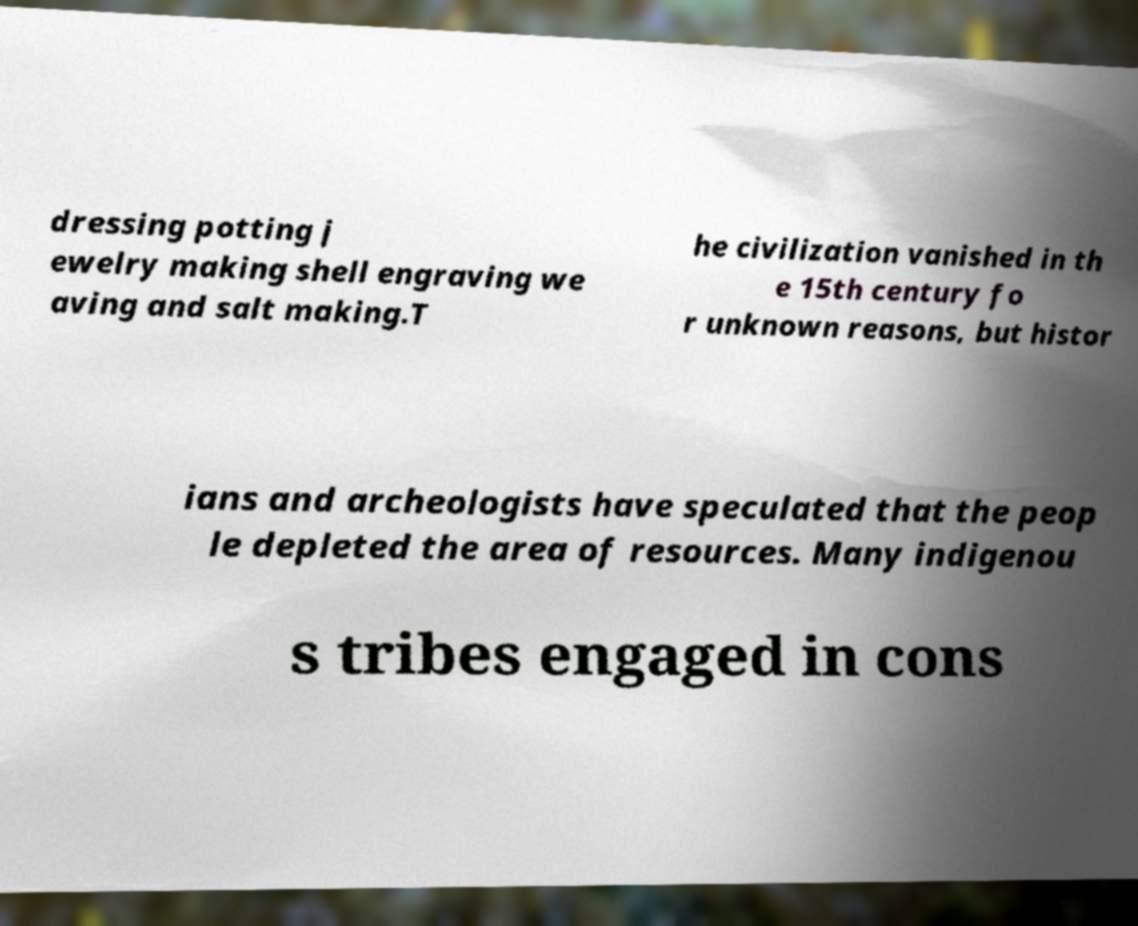There's text embedded in this image that I need extracted. Can you transcribe it verbatim? dressing potting j ewelry making shell engraving we aving and salt making.T he civilization vanished in th e 15th century fo r unknown reasons, but histor ians and archeologists have speculated that the peop le depleted the area of resources. Many indigenou s tribes engaged in cons 